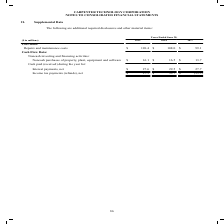According to Carpenter Technology's financial document, What was the Repairs and maintenance costs in 2019? According to the financial document, $120.4 (in millions). The relevant text states: "8 2017 Cost Data: Repairs and maintenance costs $ 120.4 $ 108.0 $ 99.1 Cash Flow Data:..." Also, What was the  Noncash purchases of property, plant, equipment and software costs in 2018? According to the financial document, $16.5 (in millions). The relevant text states: "property, plant, equipment and software $ 16.1 $ 16.5 $ 13.7 Cash paid (received) during the year for: Interest payments, net $ 27.6 $ 29.5 $ 27.7 Income..." Also, In which years was the supplemental data provided? The document contains multiple relevant values: 2019, 2018, 2017. From the document: "($ in millions) 2019 2018 2017 Cost Data: Repairs and maintenance costs $ 120.4 $ 108.0 $ 99.1 Cash Flow Data: ($ in millions) 2019 2018 2017 Cost Dat..." Additionally, In which year was Repairs and maintenance costs the largest? According to the financial document, 2019. The relevant text states: "($ in millions) 2019 2018 2017 Cost Data: Repairs and maintenance costs $ 120.4 $ 108.0 $ 99.1 Cash Flow Data:..." Also, can you calculate: What was the change in Repairs and maintenance costs in 2019 from 2018? Based on the calculation: 120.4-108.0, the result is 12.4 (in millions). This is based on the information: "ost Data: Repairs and maintenance costs $ 120.4 $ 108.0 $ 99.1 Cash Flow Data: 8 2017 Cost Data: Repairs and maintenance costs $ 120.4 $ 108.0 $ 99.1 Cash Flow Data:..." The key data points involved are: 108.0, 120.4. Also, can you calculate: What was the percentage change in Repairs and maintenance costs in 2019 from 2018? To answer this question, I need to perform calculations using the financial data. The calculation is: (120.4-108.0)/108.0, which equals 11.48 (percentage). This is based on the information: "ost Data: Repairs and maintenance costs $ 120.4 $ 108.0 $ 99.1 Cash Flow Data: 8 2017 Cost Data: Repairs and maintenance costs $ 120.4 $ 108.0 $ 99.1 Cash Flow Data:..." The key data points involved are: 108.0, 120.4. 